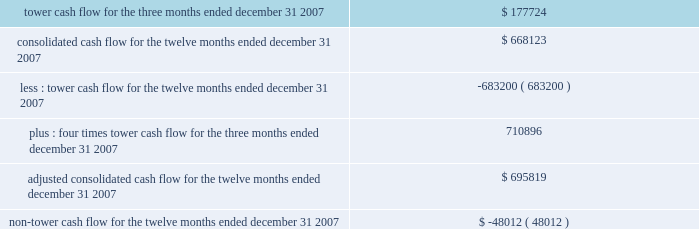The table presents tower cash flow , adjusted consolidated cash flow and non-tower cash flow for the company and its restricted subsidiaries , as defined in the indentures for the applicable notes ( in thousands ) : .

What would annualized tower cash flow be based on the tower cash flow for the fourth quarter of 2007 , in thousands? 
Rationale: last three months - q4
Computations: (177724 * 4)
Answer: 710896.0. 